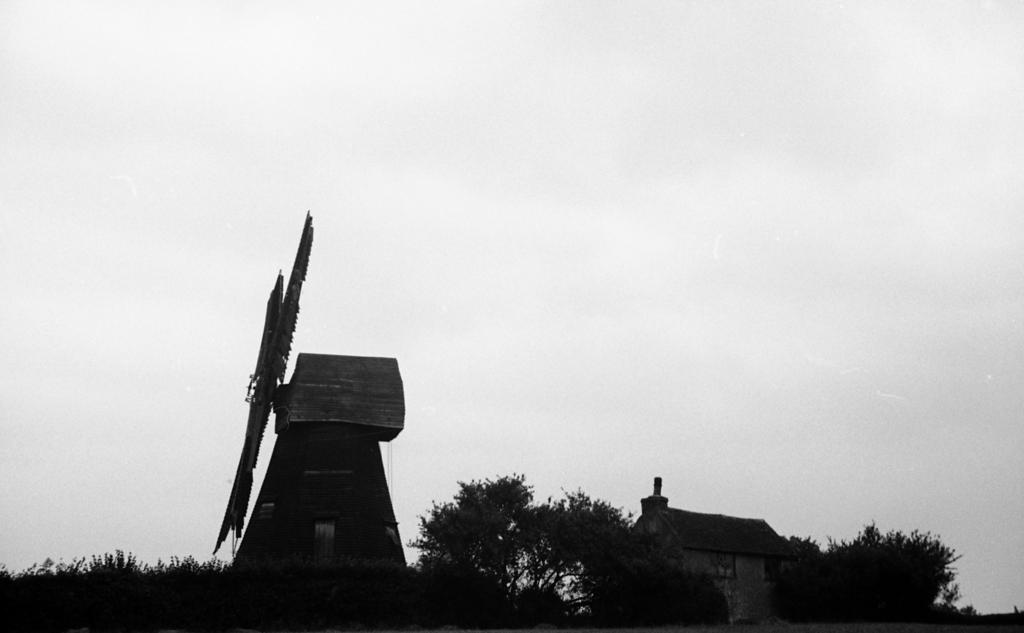What type of vegetation can be seen in the image? There are trees in the image. What type of structure is present in the image? There is a house in the image. What is the color scheme of the image? The image is in black and white. What other man-made structure can be seen in the image? There is a windmill in the image. What part of the natural environment is visible in the image? The sky is visible in the image. What committee is meeting in the image? There is no committee meeting in the image; it features trees, a house, a windmill, and the sky. What time of day is it in the image, based on the position of the sun? There is no sun visible in the image, as it is in black and white. 